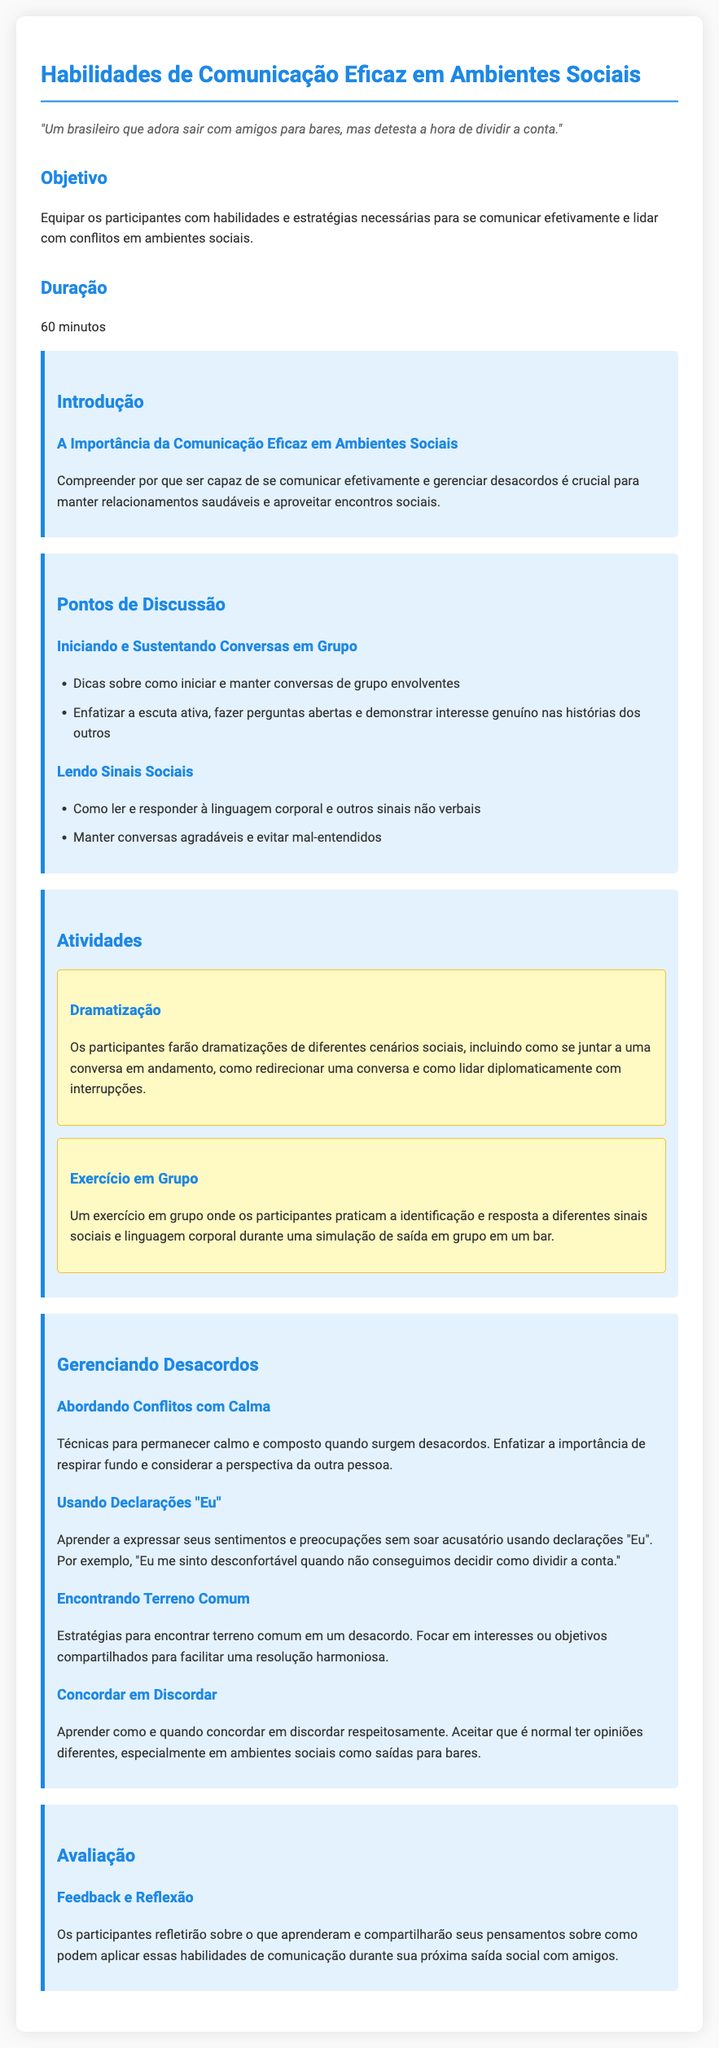Qual é o objetivo do plano de aula? O objetivo é equipar os participantes com habilidades e estratégias necessárias para se comunicar efetivamente e lidar com conflitos em ambientes sociais.
Answer: Equipar os participantes com habilidades e estratégias Qual é a duração da aula? A duração da aula é mencionada na seção de duração do documento.
Answer: 60 minutos Quais são alguns pontos de discussão abordados? Os pontos de discussão incluem iniciar e sustentar conversas e ler sinais sociais.
Answer: Iniciar e sustentar conversas em grupo, Lendo sinais sociais Como os participantes devem abordar conflitos? A seção "Gerenciando Desacordos" menciona a importância de permanecer calmo e considerar a perspectiva da outra pessoa.
Answer: Permanecer calmo e considerar a perspectiva da outra pessoa O que envolve a atividade de dramatização? A dramatização envolve os participantes fazendo dramatizações de diferentes cenários sociais, como se juntar a uma conversa em andamento.
Answer: Dramatizações de diferentes cenários sociais O que é uma técnica recomendada para expressar sentimentos? O documento recomenda usar declarações "Eu" para se expressar sem soar acusatório.
Answer: Usar declarações "Eu" Qual é o foco da seção sobre "Encontrando Terreno Comum"? O foco é encontrar interesses ou objetivos compartilhados para facilitar uma resolução harmoniosa em desacordos.
Answer: Encontrar interesses ou objetivos compartilhados O que os participantes farão na avaliação? Na avaliação, os participantes refletirão sobre o que aprenderam e compartilharão seus pensamentos.
Answer: Refletirão sobre o que aprenderam 